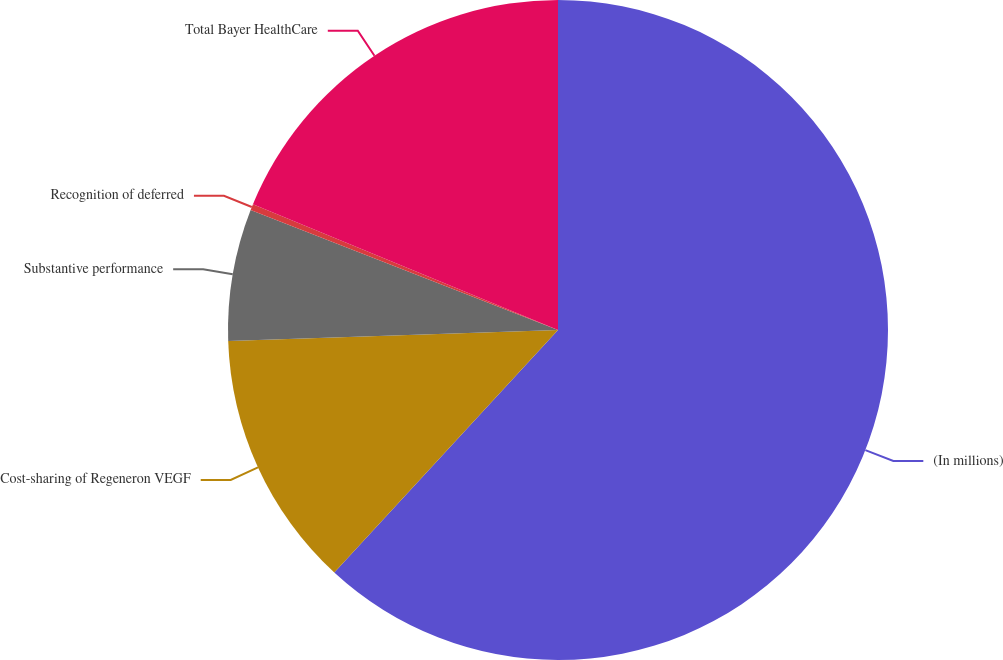Convert chart. <chart><loc_0><loc_0><loc_500><loc_500><pie_chart><fcel>(In millions)<fcel>Cost-sharing of Regeneron VEGF<fcel>Substantive performance<fcel>Recognition of deferred<fcel>Total Bayer HealthCare<nl><fcel>61.85%<fcel>12.61%<fcel>6.46%<fcel>0.3%<fcel>18.77%<nl></chart> 